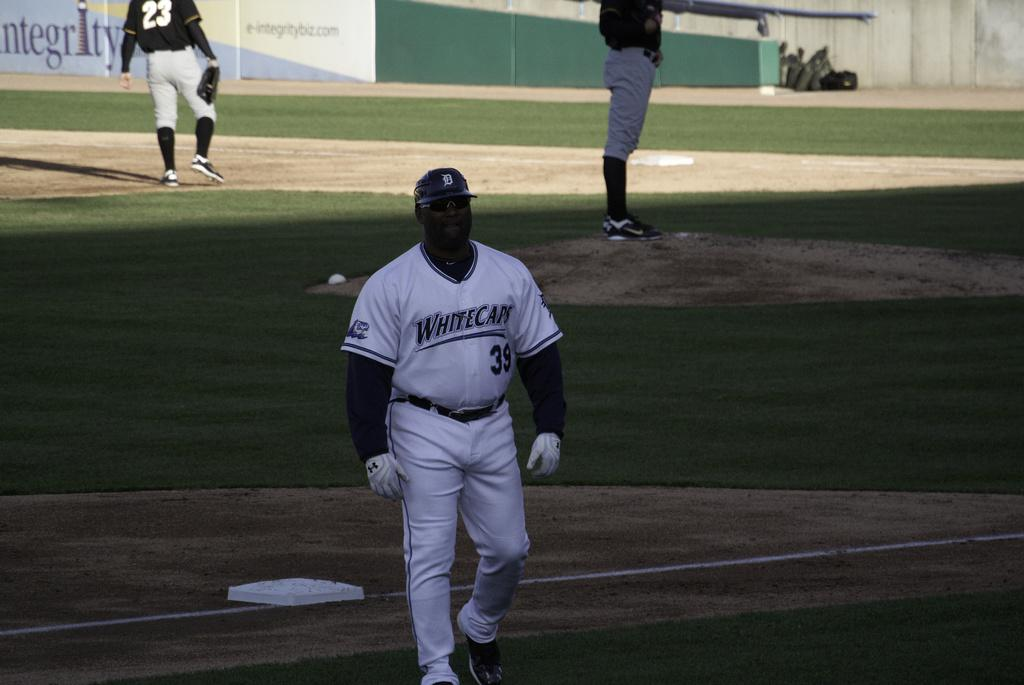<image>
Present a compact description of the photo's key features. The player here is playing for the Whitecaps 